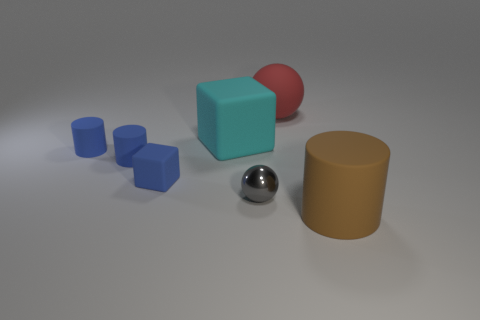Subtract all red spheres. Subtract all purple cylinders. How many spheres are left? 1 Add 2 large cyan rubber things. How many objects exist? 9 Subtract all spheres. How many objects are left? 5 Add 3 cylinders. How many cylinders exist? 6 Subtract 1 brown cylinders. How many objects are left? 6 Subtract all small metallic balls. Subtract all small blue rubber cubes. How many objects are left? 5 Add 3 small metallic objects. How many small metallic objects are left? 4 